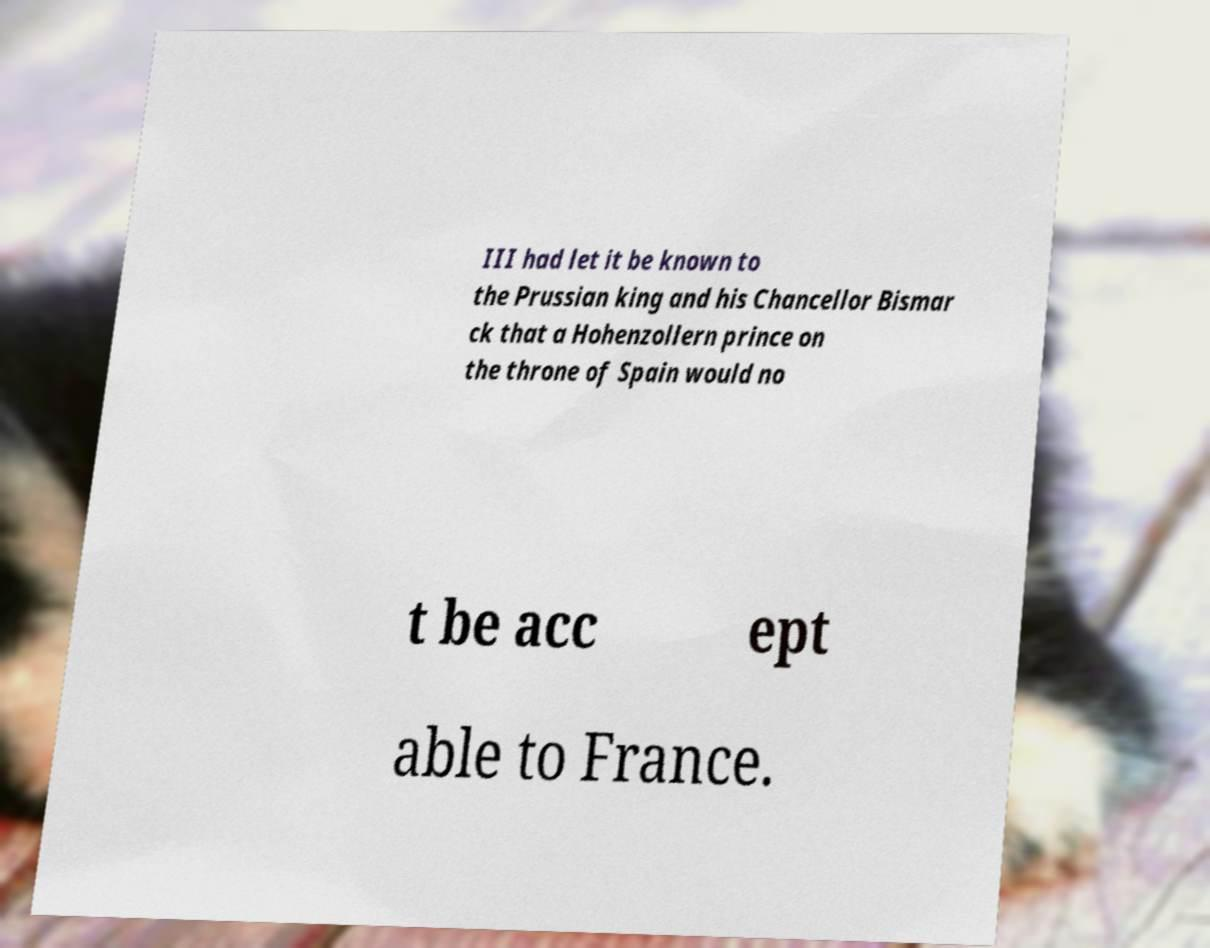There's text embedded in this image that I need extracted. Can you transcribe it verbatim? III had let it be known to the Prussian king and his Chancellor Bismar ck that a Hohenzollern prince on the throne of Spain would no t be acc ept able to France. 